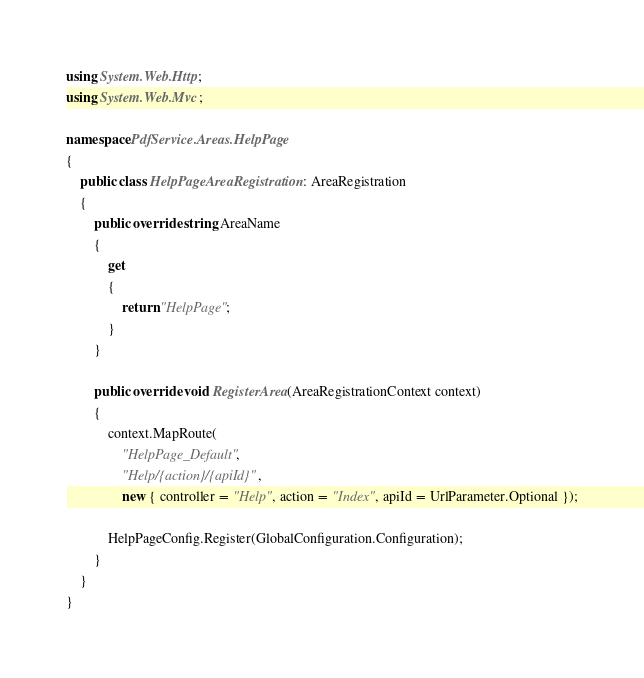<code> <loc_0><loc_0><loc_500><loc_500><_C#_>using System.Web.Http;
using System.Web.Mvc;

namespace PdfService.Areas.HelpPage
{
    public class HelpPageAreaRegistration : AreaRegistration
    {
        public override string AreaName
        {
            get
            {
                return "HelpPage";
            }
        }

        public override void RegisterArea(AreaRegistrationContext context)
        {
            context.MapRoute(
                "HelpPage_Default",
                "Help/{action}/{apiId}",
                new { controller = "Help", action = "Index", apiId = UrlParameter.Optional });

            HelpPageConfig.Register(GlobalConfiguration.Configuration);
        }
    }
}</code> 